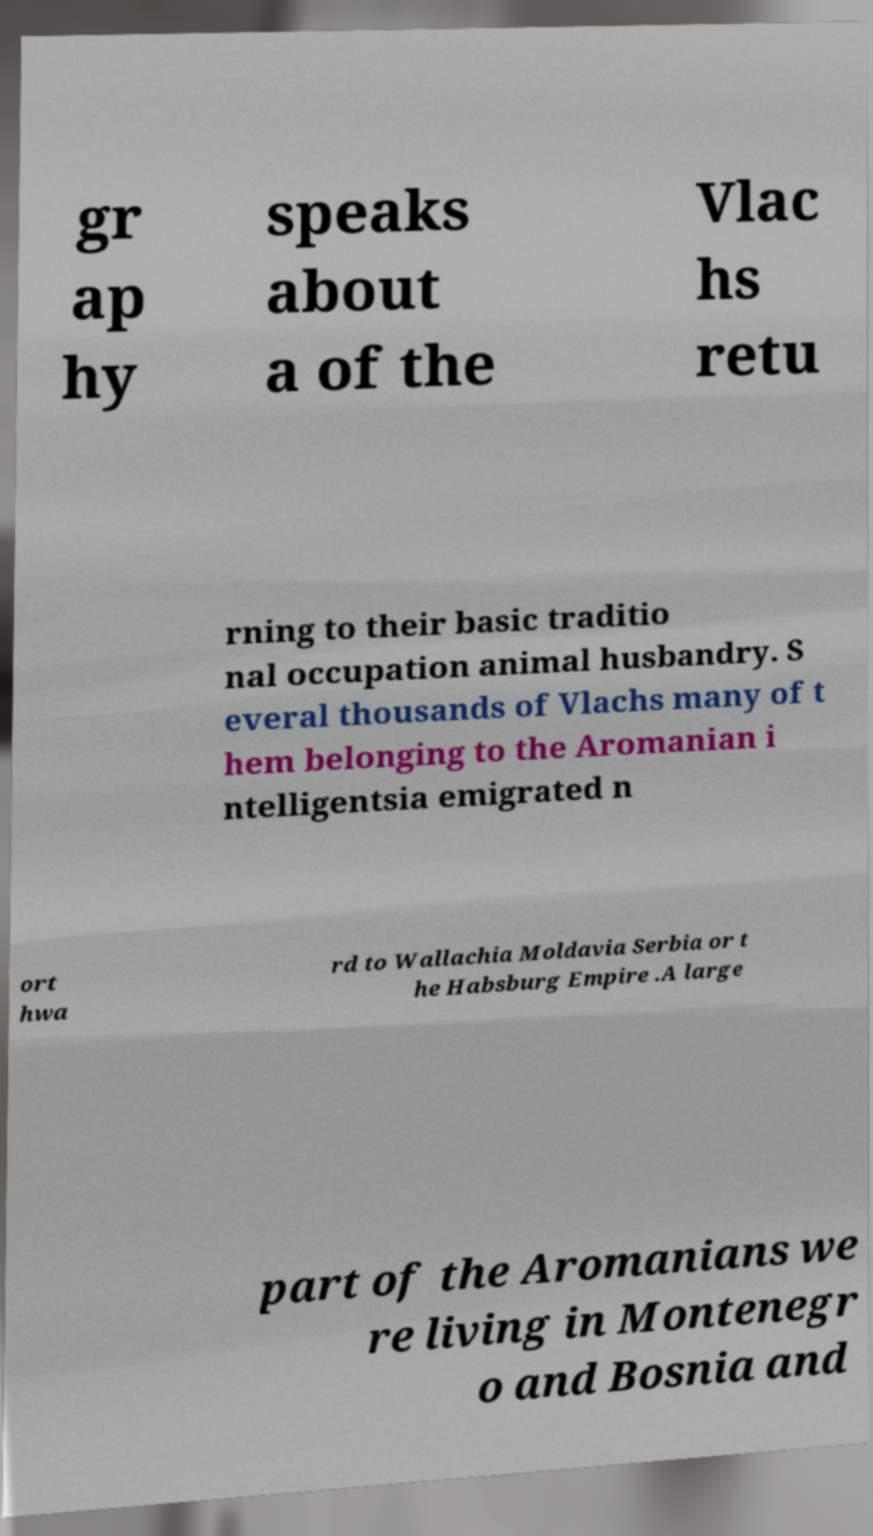Can you accurately transcribe the text from the provided image for me? gr ap hy speaks about a of the Vlac hs retu rning to their basic traditio nal occupation animal husbandry. S everal thousands of Vlachs many of t hem belonging to the Aromanian i ntelligentsia emigrated n ort hwa rd to Wallachia Moldavia Serbia or t he Habsburg Empire .A large part of the Aromanians we re living in Montenegr o and Bosnia and 